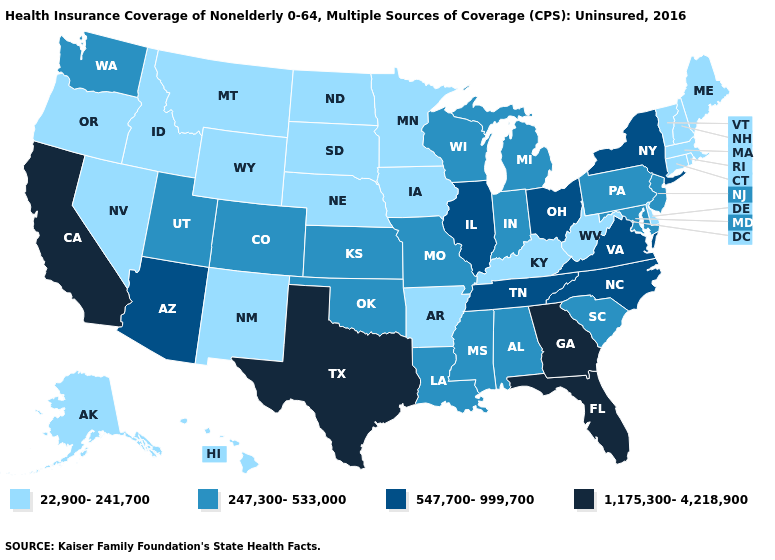Name the states that have a value in the range 22,900-241,700?
Short answer required. Alaska, Arkansas, Connecticut, Delaware, Hawaii, Idaho, Iowa, Kentucky, Maine, Massachusetts, Minnesota, Montana, Nebraska, Nevada, New Hampshire, New Mexico, North Dakota, Oregon, Rhode Island, South Dakota, Vermont, West Virginia, Wyoming. What is the lowest value in the Northeast?
Write a very short answer. 22,900-241,700. What is the value of Hawaii?
Give a very brief answer. 22,900-241,700. Among the states that border Tennessee , does Missouri have the lowest value?
Be succinct. No. Does Texas have the highest value in the USA?
Short answer required. Yes. Name the states that have a value in the range 247,300-533,000?
Short answer required. Alabama, Colorado, Indiana, Kansas, Louisiana, Maryland, Michigan, Mississippi, Missouri, New Jersey, Oklahoma, Pennsylvania, South Carolina, Utah, Washington, Wisconsin. Name the states that have a value in the range 547,700-999,700?
Write a very short answer. Arizona, Illinois, New York, North Carolina, Ohio, Tennessee, Virginia. Among the states that border Oregon , does Nevada have the highest value?
Short answer required. No. What is the value of California?
Quick response, please. 1,175,300-4,218,900. Is the legend a continuous bar?
Answer briefly. No. Does Minnesota have the highest value in the MidWest?
Short answer required. No. What is the highest value in states that border Massachusetts?
Be succinct. 547,700-999,700. Name the states that have a value in the range 1,175,300-4,218,900?
Be succinct. California, Florida, Georgia, Texas. Does Minnesota have the same value as Arkansas?
Short answer required. Yes. Name the states that have a value in the range 22,900-241,700?
Give a very brief answer. Alaska, Arkansas, Connecticut, Delaware, Hawaii, Idaho, Iowa, Kentucky, Maine, Massachusetts, Minnesota, Montana, Nebraska, Nevada, New Hampshire, New Mexico, North Dakota, Oregon, Rhode Island, South Dakota, Vermont, West Virginia, Wyoming. 